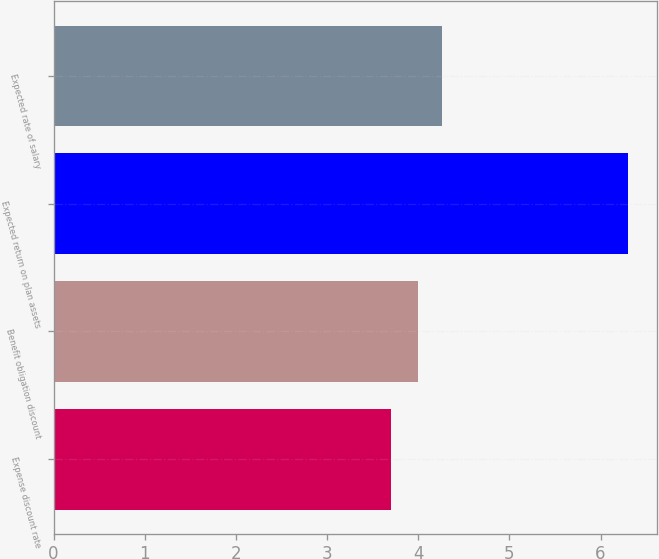Convert chart to OTSL. <chart><loc_0><loc_0><loc_500><loc_500><bar_chart><fcel>Expense discount rate<fcel>Benefit obligation discount<fcel>Expected return on plan assets<fcel>Expected rate of salary<nl><fcel>3.7<fcel>4<fcel>6.3<fcel>4.26<nl></chart> 